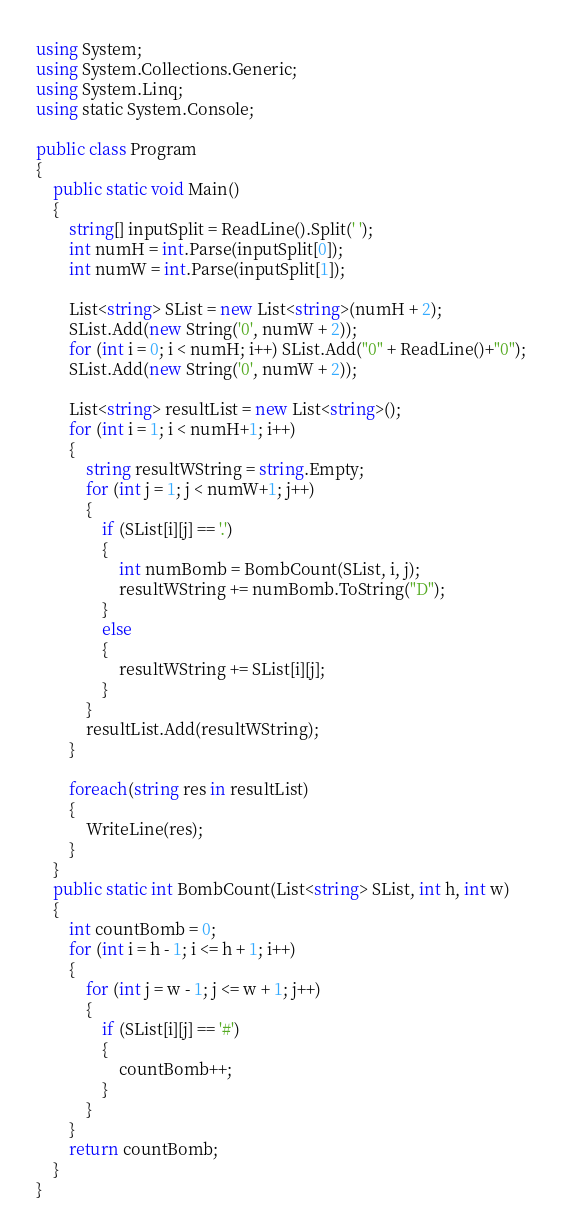<code> <loc_0><loc_0><loc_500><loc_500><_C#_>using System;
using System.Collections.Generic;
using System.Linq;
using static System.Console;

public class Program
{
    public static void Main()
    {
        string[] inputSplit = ReadLine().Split(' ');
        int numH = int.Parse(inputSplit[0]);
        int numW = int.Parse(inputSplit[1]);
      
        List<string> SList = new List<string>(numH + 2);
        SList.Add(new String('0', numW + 2));
        for (int i = 0; i < numH; i++) SList.Add("0" + ReadLine()+"0");
        SList.Add(new String('0', numW + 2));

        List<string> resultList = new List<string>();
        for (int i = 1; i < numH+1; i++)
        {
            string resultWString = string.Empty;
            for (int j = 1; j < numW+1; j++)
            {
                if (SList[i][j] == '.')
                {
                    int numBomb = BombCount(SList, i, j);
                    resultWString += numBomb.ToString("D");
                }
                else
                {
                    resultWString += SList[i][j];
                }
            }
            resultList.Add(resultWString);
        }

        foreach(string res in resultList)
        {
            WriteLine(res);
        }
    }
    public static int BombCount(List<string> SList, int h, int w)
    {
        int countBomb = 0;
        for (int i = h - 1; i <= h + 1; i++)
        {
            for (int j = w - 1; j <= w + 1; j++)
            {
                if (SList[i][j] == '#')
                {
                    countBomb++;
                }
            }
        }
        return countBomb;
    }
}</code> 